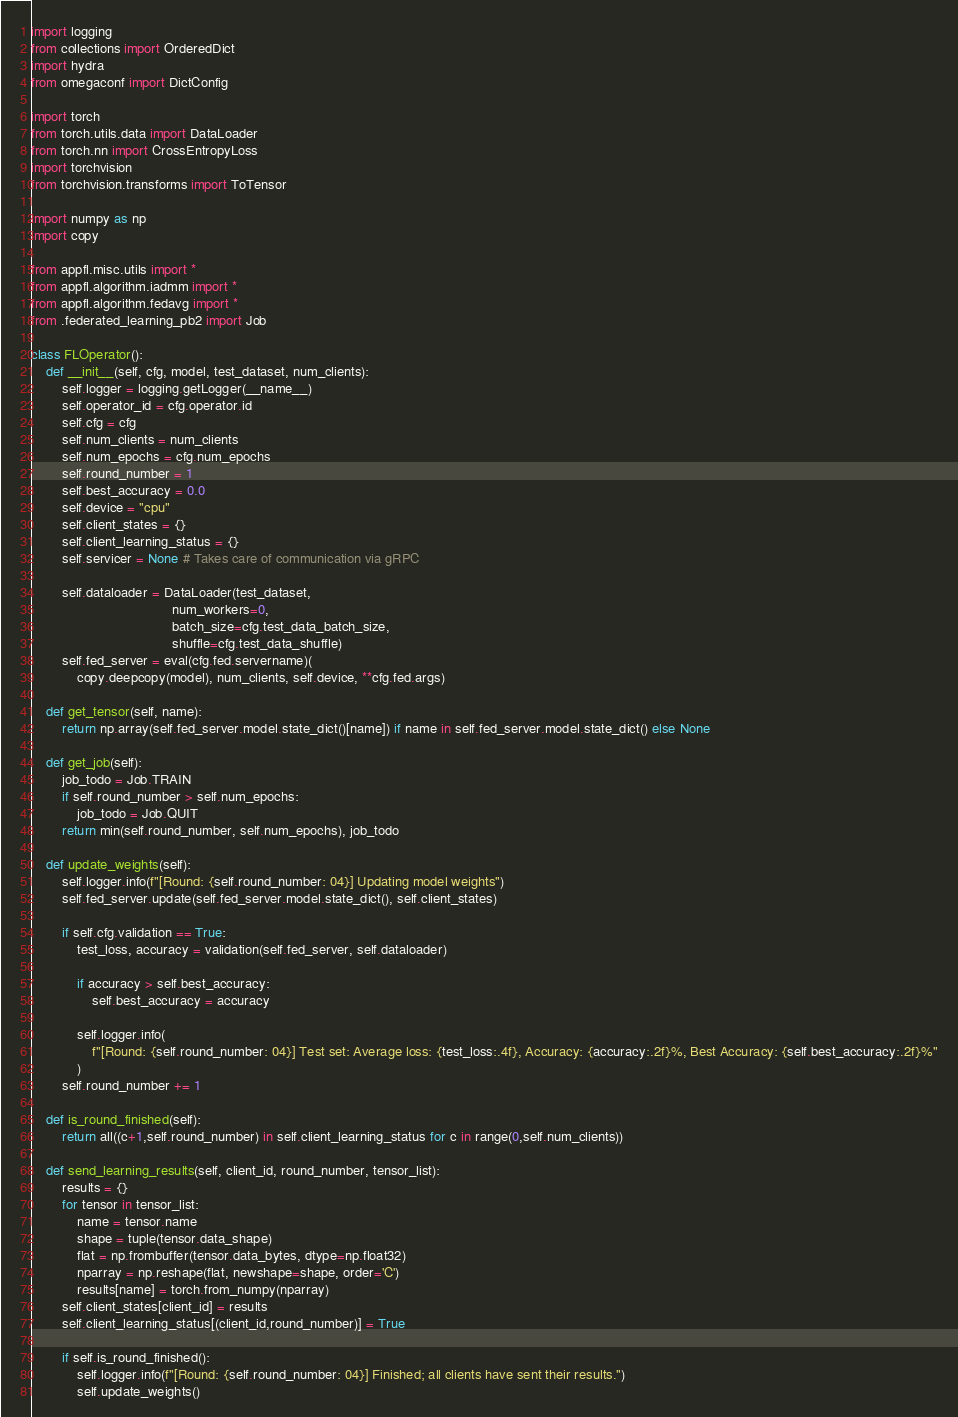Convert code to text. <code><loc_0><loc_0><loc_500><loc_500><_Python_>import logging
from collections import OrderedDict
import hydra
from omegaconf import DictConfig

import torch
from torch.utils.data import DataLoader
from torch.nn import CrossEntropyLoss
import torchvision
from torchvision.transforms import ToTensor

import numpy as np
import copy

from appfl.misc.utils import *
from appfl.algorithm.iadmm import *
from appfl.algorithm.fedavg import *
from .federated_learning_pb2 import Job

class FLOperator():
    def __init__(self, cfg, model, test_dataset, num_clients):
        self.logger = logging.getLogger(__name__)
        self.operator_id = cfg.operator.id
        self.cfg = cfg
        self.num_clients = num_clients
        self.num_epochs = cfg.num_epochs
        self.round_number = 1
        self.best_accuracy = 0.0
        self.device = "cpu"
        self.client_states = {}
        self.client_learning_status = {}
        self.servicer = None # Takes care of communication via gRPC

        self.dataloader = DataLoader(test_dataset,
                                     num_workers=0,
                                     batch_size=cfg.test_data_batch_size,
                                     shuffle=cfg.test_data_shuffle)
        self.fed_server = eval(cfg.fed.servername)(
            copy.deepcopy(model), num_clients, self.device, **cfg.fed.args)

    def get_tensor(self, name):
        return np.array(self.fed_server.model.state_dict()[name]) if name in self.fed_server.model.state_dict() else None

    def get_job(self):
        job_todo = Job.TRAIN
        if self.round_number > self.num_epochs:
            job_todo = Job.QUIT
        return min(self.round_number, self.num_epochs), job_todo

    def update_weights(self):
        self.logger.info(f"[Round: {self.round_number: 04}] Updating model weights")
        self.fed_server.update(self.fed_server.model.state_dict(), self.client_states)

        if self.cfg.validation == True:
            test_loss, accuracy = validation(self.fed_server, self.dataloader)

            if accuracy > self.best_accuracy:
                self.best_accuracy = accuracy

            self.logger.info(
                f"[Round: {self.round_number: 04}] Test set: Average loss: {test_loss:.4f}, Accuracy: {accuracy:.2f}%, Best Accuracy: {self.best_accuracy:.2f}%"
            )
        self.round_number += 1

    def is_round_finished(self):
        return all((c+1,self.round_number) in self.client_learning_status for c in range(0,self.num_clients))

    def send_learning_results(self, client_id, round_number, tensor_list):
        results = {}
        for tensor in tensor_list:
            name = tensor.name
            shape = tuple(tensor.data_shape)
            flat = np.frombuffer(tensor.data_bytes, dtype=np.float32)
            nparray = np.reshape(flat, newshape=shape, order='C')
            results[name] = torch.from_numpy(nparray)
        self.client_states[client_id] = results
        self.client_learning_status[(client_id,round_number)] = True

        if self.is_round_finished():
            self.logger.info(f"[Round: {self.round_number: 04}] Finished; all clients have sent their results.")
            self.update_weights()
</code> 